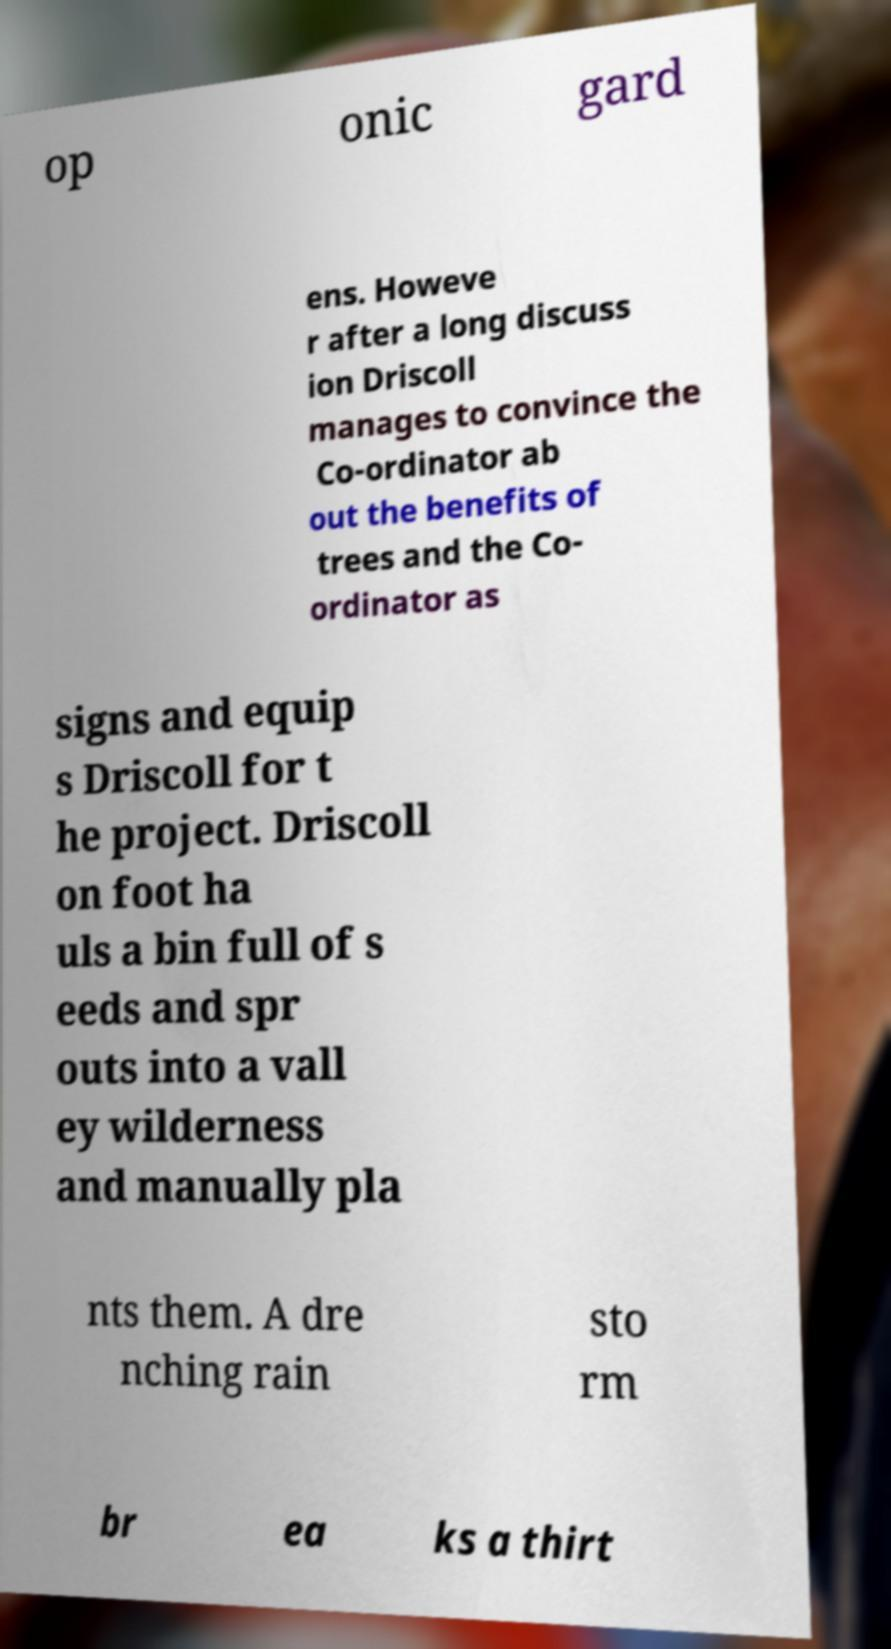Can you accurately transcribe the text from the provided image for me? op onic gard ens. Howeve r after a long discuss ion Driscoll manages to convince the Co-ordinator ab out the benefits of trees and the Co- ordinator as signs and equip s Driscoll for t he project. Driscoll on foot ha uls a bin full of s eeds and spr outs into a vall ey wilderness and manually pla nts them. A dre nching rain sto rm br ea ks a thirt 